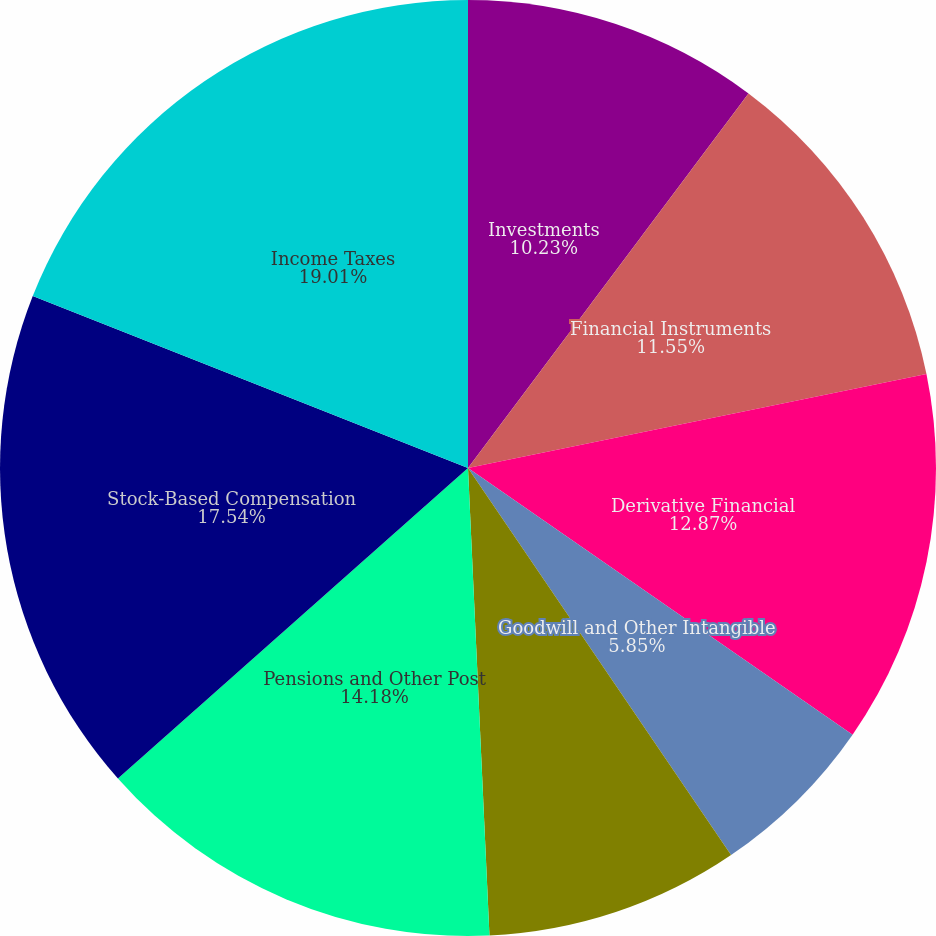<chart> <loc_0><loc_0><loc_500><loc_500><pie_chart><fcel>Investments<fcel>Financial Instruments<fcel>Derivative Financial<fcel>Goodwill and Other Intangible<fcel>Property Plant and Equipment<fcel>Pensions and Other Post<fcel>Stock-Based Compensation<fcel>Income Taxes<nl><fcel>10.23%<fcel>11.55%<fcel>12.87%<fcel>5.85%<fcel>8.77%<fcel>14.18%<fcel>17.54%<fcel>19.01%<nl></chart> 